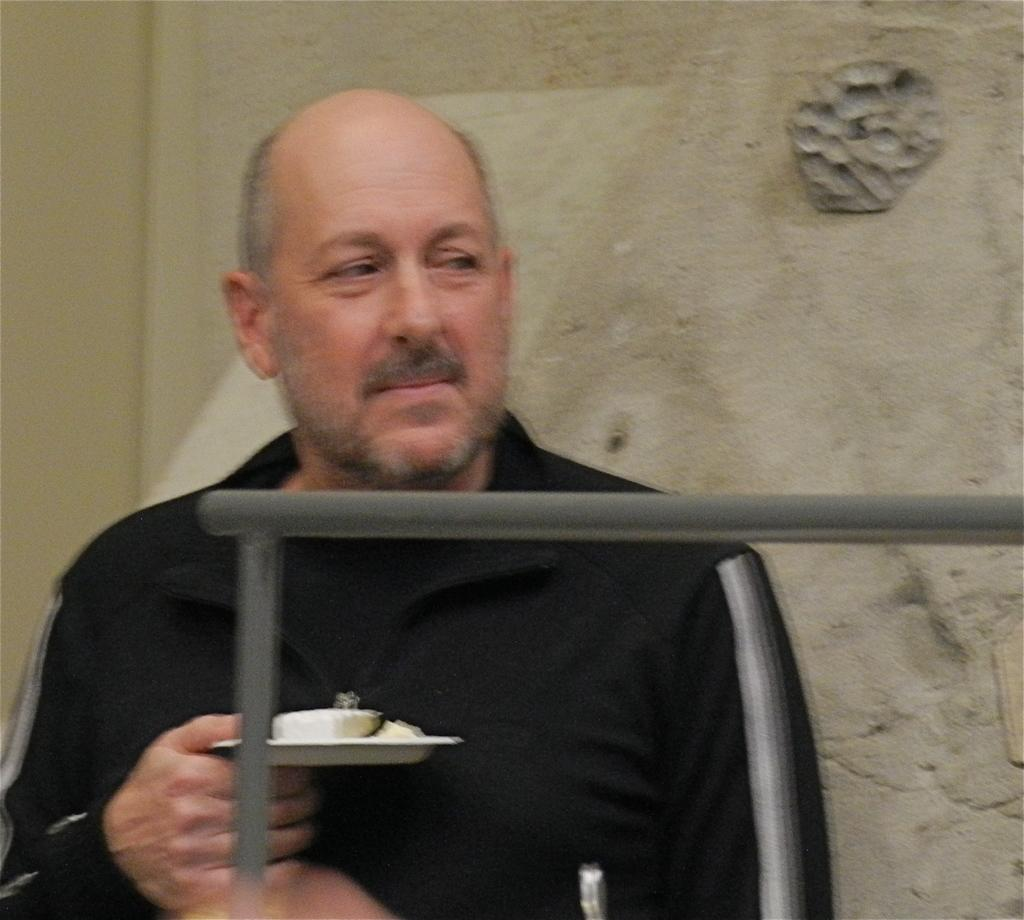What can be seen in the image? There is a person in the image. What is the person holding? The person is holding an object. Can you describe the metallic object in the image? There is a metallic object in the image. What is the background of the image? There is a wall in the image. What type of orange is being divided for peace in the image? There is no orange or division for peace present in the image. 